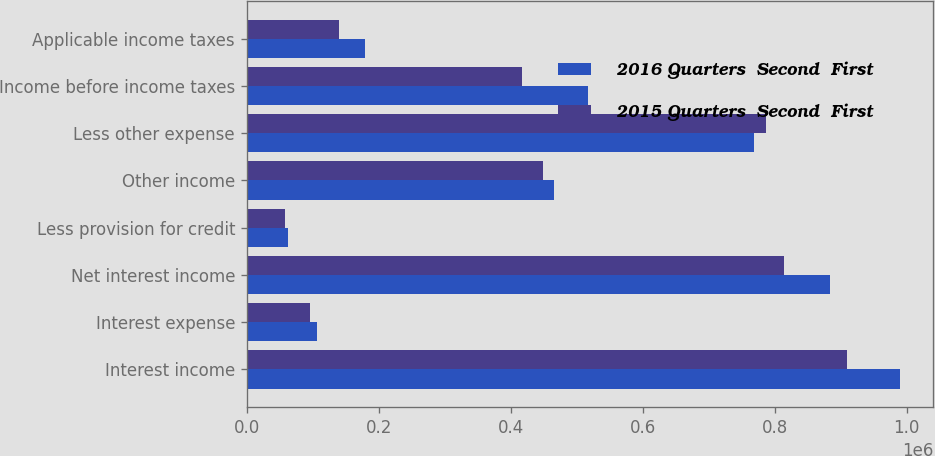Convert chart to OTSL. <chart><loc_0><loc_0><loc_500><loc_500><stacked_bar_chart><ecel><fcel>Interest income<fcel>Interest expense<fcel>Net interest income<fcel>Less provision for credit<fcel>Other income<fcel>Less other expense<fcel>Income before income taxes<fcel>Applicable income taxes<nl><fcel>2016 Quarters  Second  First<fcel>990284<fcel>107137<fcel>883147<fcel>62000<fcel>465459<fcel>769103<fcel>517503<fcel>179549<nl><fcel>2015 Quarters  Second  First<fcel>908734<fcel>95333<fcel>813401<fcel>58000<fcel>448108<fcel>786113<fcel>417396<fcel>140074<nl></chart> 